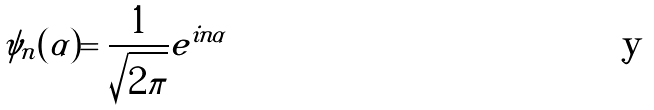<formula> <loc_0><loc_0><loc_500><loc_500>\psi _ { n } ( \alpha ) = \frac { 1 } { \sqrt { 2 \pi } } e ^ { i n \alpha }</formula> 